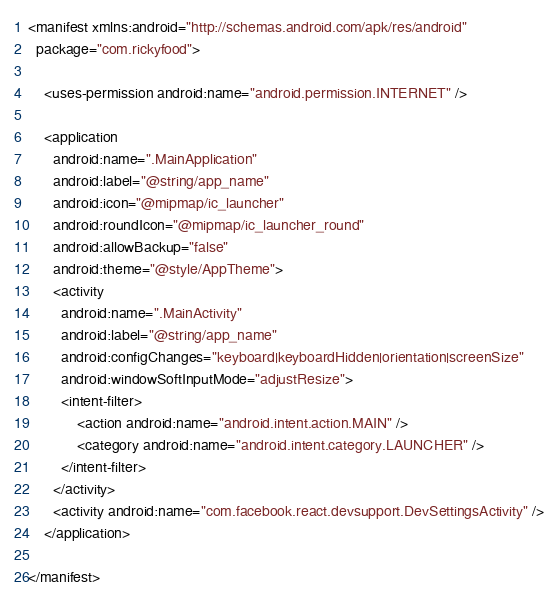<code> <loc_0><loc_0><loc_500><loc_500><_XML_><manifest xmlns:android="http://schemas.android.com/apk/res/android"
  package="com.rickyfood">

    <uses-permission android:name="android.permission.INTERNET" />

    <application
      android:name=".MainApplication"
      android:label="@string/app_name"
      android:icon="@mipmap/ic_launcher"
      android:roundIcon="@mipmap/ic_launcher_round"
      android:allowBackup="false"
      android:theme="@style/AppTheme">
      <activity
        android:name=".MainActivity"
        android:label="@string/app_name"
        android:configChanges="keyboard|keyboardHidden|orientation|screenSize"
        android:windowSoftInputMode="adjustResize">
        <intent-filter>
            <action android:name="android.intent.action.MAIN" />
            <category android:name="android.intent.category.LAUNCHER" />
        </intent-filter>
      </activity>
      <activity android:name="com.facebook.react.devsupport.DevSettingsActivity" />
    </application>

</manifest>
</code> 